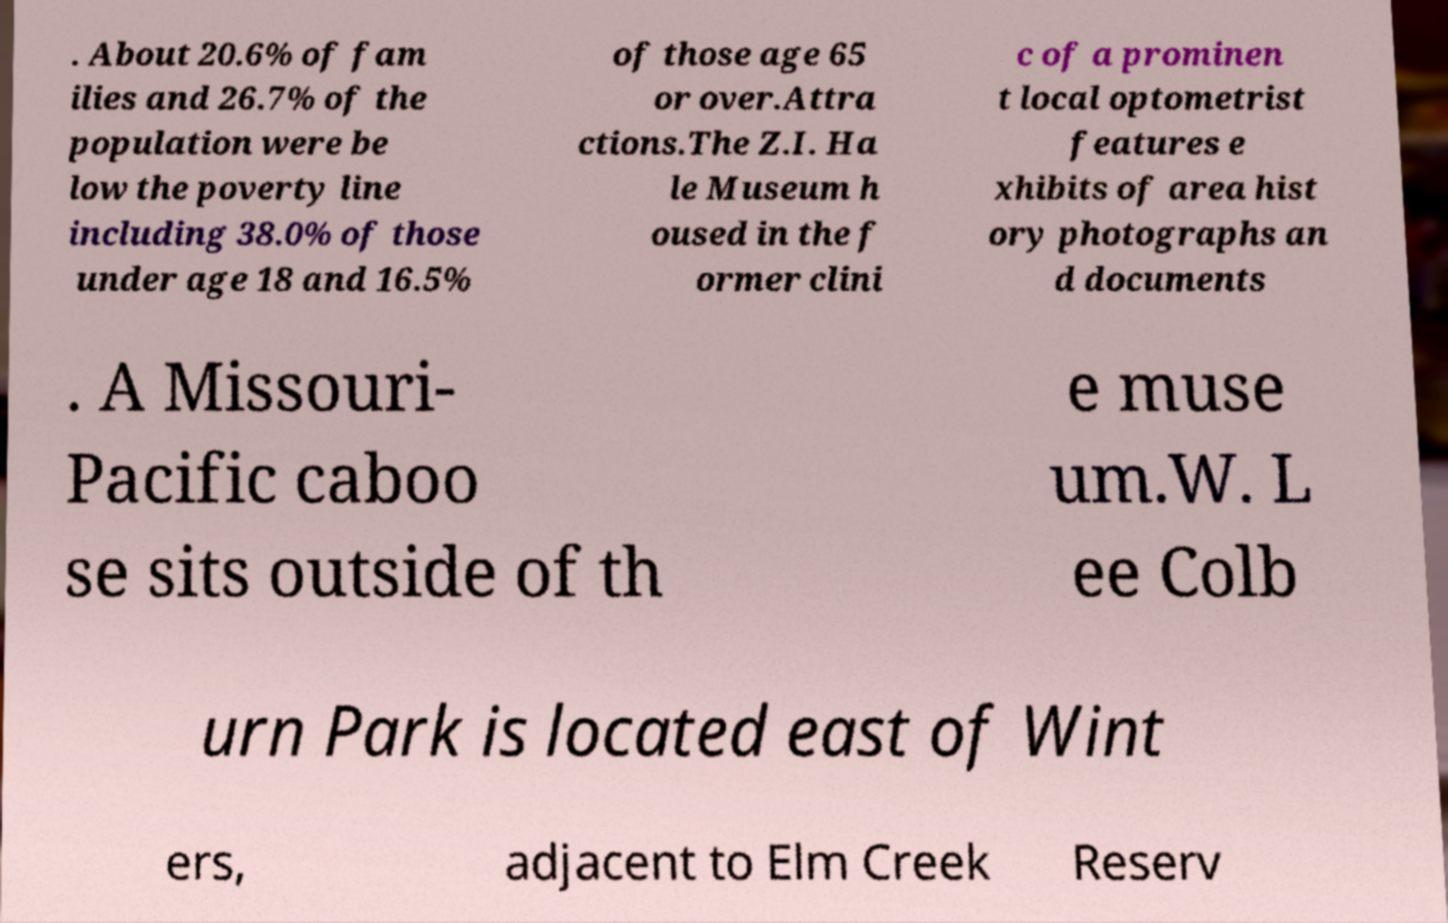For documentation purposes, I need the text within this image transcribed. Could you provide that? . About 20.6% of fam ilies and 26.7% of the population were be low the poverty line including 38.0% of those under age 18 and 16.5% of those age 65 or over.Attra ctions.The Z.I. Ha le Museum h oused in the f ormer clini c of a prominen t local optometrist features e xhibits of area hist ory photographs an d documents . A Missouri- Pacific caboo se sits outside of th e muse um.W. L ee Colb urn Park is located east of Wint ers, adjacent to Elm Creek Reserv 